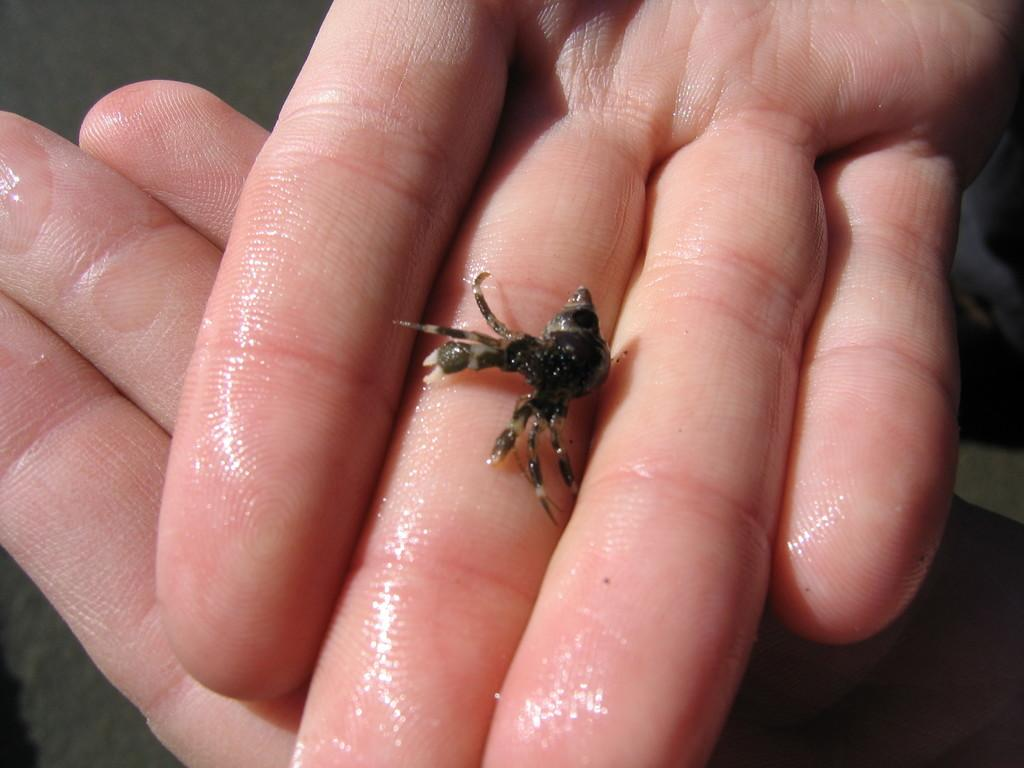What type of creature is present in the image? There is an insect in the image. Where is the insect located in the image? The insect is in a person's hand. What type of pets does the person desire in the image? There is no indication of any pets or desires in the image; it only features an insect in a person's hand. 